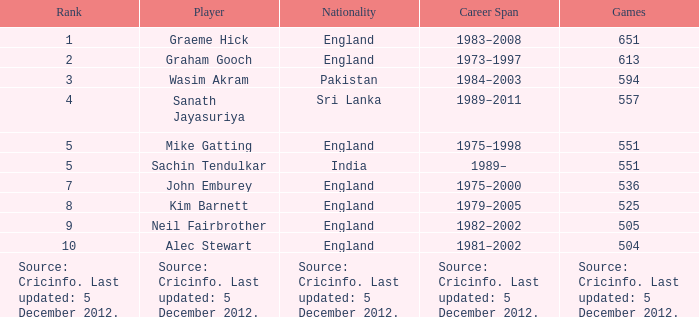What is Graham Gooch's nationality? England. 